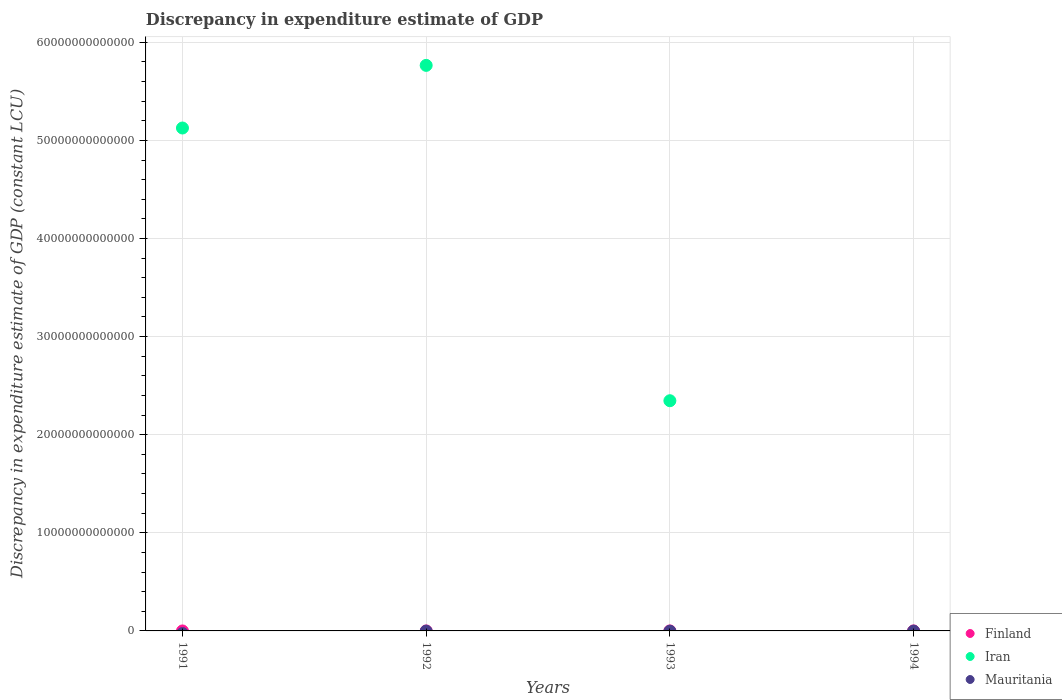How many different coloured dotlines are there?
Offer a terse response. 1. Is the number of dotlines equal to the number of legend labels?
Make the answer very short. No. Across all years, what is the maximum discrepancy in expenditure estimate of GDP in Iran?
Your answer should be compact. 5.76e+13. Across all years, what is the minimum discrepancy in expenditure estimate of GDP in Iran?
Ensure brevity in your answer.  0. What is the total discrepancy in expenditure estimate of GDP in Iran in the graph?
Keep it short and to the point. 1.32e+14. What is the ratio of the discrepancy in expenditure estimate of GDP in Iran in 1991 to that in 1993?
Offer a very short reply. 2.18. What is the difference between the highest and the second highest discrepancy in expenditure estimate of GDP in Iran?
Offer a very short reply. 6.38e+12. What is the difference between the highest and the lowest discrepancy in expenditure estimate of GDP in Iran?
Provide a short and direct response. 5.76e+13. Does the discrepancy in expenditure estimate of GDP in Finland monotonically increase over the years?
Offer a very short reply. Yes. Is the discrepancy in expenditure estimate of GDP in Finland strictly greater than the discrepancy in expenditure estimate of GDP in Mauritania over the years?
Make the answer very short. Yes. How many dotlines are there?
Offer a terse response. 1. What is the difference between two consecutive major ticks on the Y-axis?
Your answer should be compact. 1.00e+13. Are the values on the major ticks of Y-axis written in scientific E-notation?
Offer a very short reply. No. Does the graph contain grids?
Offer a very short reply. Yes. Where does the legend appear in the graph?
Your answer should be compact. Bottom right. What is the title of the graph?
Provide a short and direct response. Discrepancy in expenditure estimate of GDP. What is the label or title of the Y-axis?
Your response must be concise. Discrepancy in expenditure estimate of GDP (constant LCU). What is the Discrepancy in expenditure estimate of GDP (constant LCU) in Finland in 1991?
Give a very brief answer. 0. What is the Discrepancy in expenditure estimate of GDP (constant LCU) of Iran in 1991?
Make the answer very short. 5.13e+13. What is the Discrepancy in expenditure estimate of GDP (constant LCU) in Mauritania in 1991?
Give a very brief answer. 0. What is the Discrepancy in expenditure estimate of GDP (constant LCU) of Finland in 1992?
Provide a succinct answer. 0. What is the Discrepancy in expenditure estimate of GDP (constant LCU) in Iran in 1992?
Make the answer very short. 5.76e+13. What is the Discrepancy in expenditure estimate of GDP (constant LCU) in Iran in 1993?
Keep it short and to the point. 2.35e+13. Across all years, what is the maximum Discrepancy in expenditure estimate of GDP (constant LCU) of Iran?
Your answer should be very brief. 5.76e+13. What is the total Discrepancy in expenditure estimate of GDP (constant LCU) in Finland in the graph?
Ensure brevity in your answer.  0. What is the total Discrepancy in expenditure estimate of GDP (constant LCU) of Iran in the graph?
Provide a succinct answer. 1.32e+14. What is the total Discrepancy in expenditure estimate of GDP (constant LCU) of Mauritania in the graph?
Provide a short and direct response. 0. What is the difference between the Discrepancy in expenditure estimate of GDP (constant LCU) of Iran in 1991 and that in 1992?
Your answer should be very brief. -6.38e+12. What is the difference between the Discrepancy in expenditure estimate of GDP (constant LCU) of Iran in 1991 and that in 1993?
Provide a short and direct response. 2.78e+13. What is the difference between the Discrepancy in expenditure estimate of GDP (constant LCU) of Iran in 1992 and that in 1993?
Offer a very short reply. 3.42e+13. What is the average Discrepancy in expenditure estimate of GDP (constant LCU) of Iran per year?
Give a very brief answer. 3.31e+13. What is the average Discrepancy in expenditure estimate of GDP (constant LCU) of Mauritania per year?
Your answer should be very brief. 0. What is the ratio of the Discrepancy in expenditure estimate of GDP (constant LCU) of Iran in 1991 to that in 1992?
Your response must be concise. 0.89. What is the ratio of the Discrepancy in expenditure estimate of GDP (constant LCU) in Iran in 1991 to that in 1993?
Give a very brief answer. 2.18. What is the ratio of the Discrepancy in expenditure estimate of GDP (constant LCU) in Iran in 1992 to that in 1993?
Keep it short and to the point. 2.46. What is the difference between the highest and the second highest Discrepancy in expenditure estimate of GDP (constant LCU) in Iran?
Give a very brief answer. 6.38e+12. What is the difference between the highest and the lowest Discrepancy in expenditure estimate of GDP (constant LCU) in Iran?
Offer a terse response. 5.76e+13. 